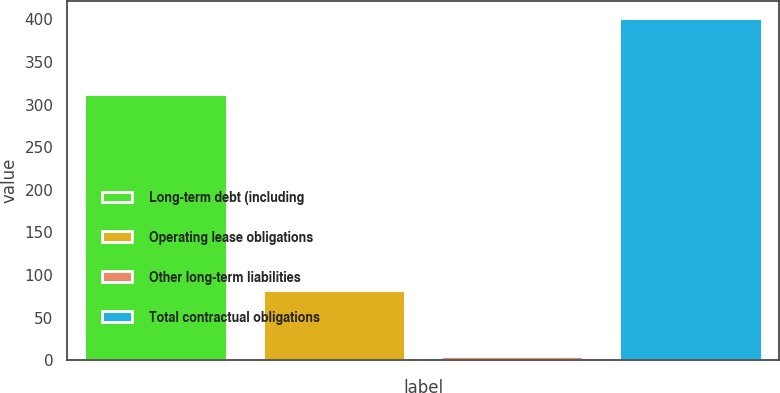Convert chart to OTSL. <chart><loc_0><loc_0><loc_500><loc_500><bar_chart><fcel>Long-term debt (including<fcel>Operating lease obligations<fcel>Other long-term liabilities<fcel>Total contractual obligations<nl><fcel>313<fcel>83<fcel>5<fcel>402<nl></chart> 